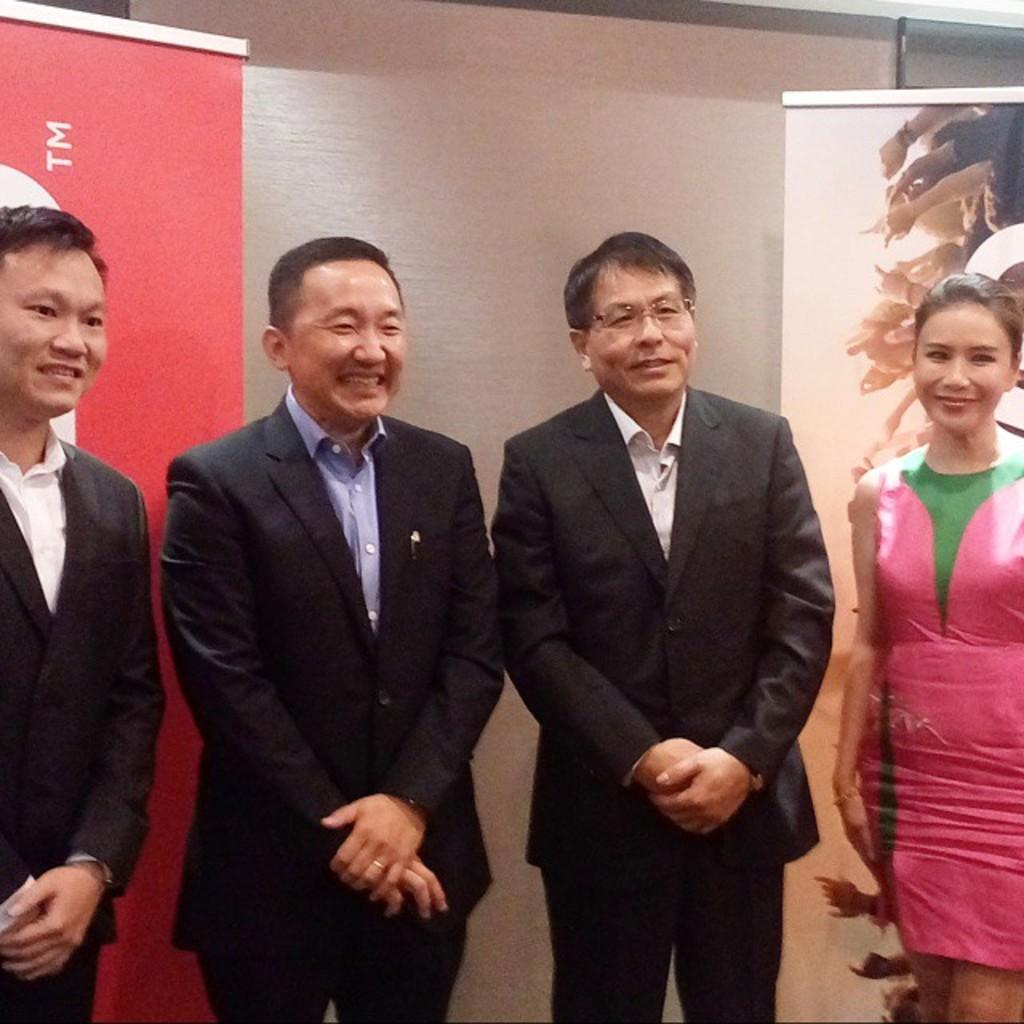How many people are in the image? There are four people in the image, three males and a female. What are the individuals doing in the image? The individuals are standing. What can be seen in the background of the image? There are posters and a wall in the background of the image. What type of insect can be seen crawling on the wall in the image? There is no insect visible on the wall in the image. What time of day is it in the image, considering the position of the sun? The position of the sun is not visible in the image, so it cannot be determined from the image. 